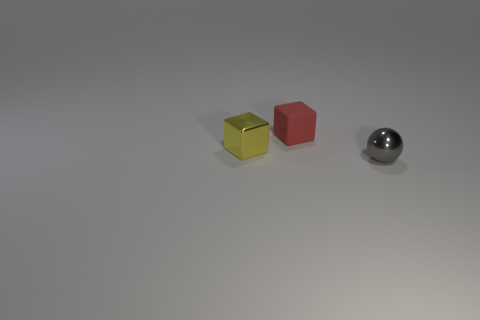The tiny yellow thing that is the same material as the sphere is what shape?
Provide a succinct answer. Cube. There is a metal object in front of the small shiny object left of the metallic object to the right of the small rubber object; what shape is it?
Provide a short and direct response. Sphere. Are there more matte objects than red rubber cylinders?
Provide a short and direct response. Yes. What is the material of the other yellow object that is the same shape as the matte thing?
Give a very brief answer. Metal. Does the gray ball have the same material as the small yellow object?
Ensure brevity in your answer.  Yes. Are there more tiny matte things that are behind the yellow thing than big brown matte cubes?
Provide a succinct answer. Yes. There is a tiny cube that is to the left of the block on the right side of the metallic thing on the left side of the tiny gray object; what is its material?
Your answer should be very brief. Metal. How many things are either rubber things or blocks to the left of the tiny matte block?
Offer a terse response. 2. Is the number of tiny cubes behind the tiny shiny cube greater than the number of red matte objects that are in front of the small metal ball?
Your answer should be compact. Yes. How many things are small brown metal cylinders or metallic objects?
Your answer should be compact. 2. 